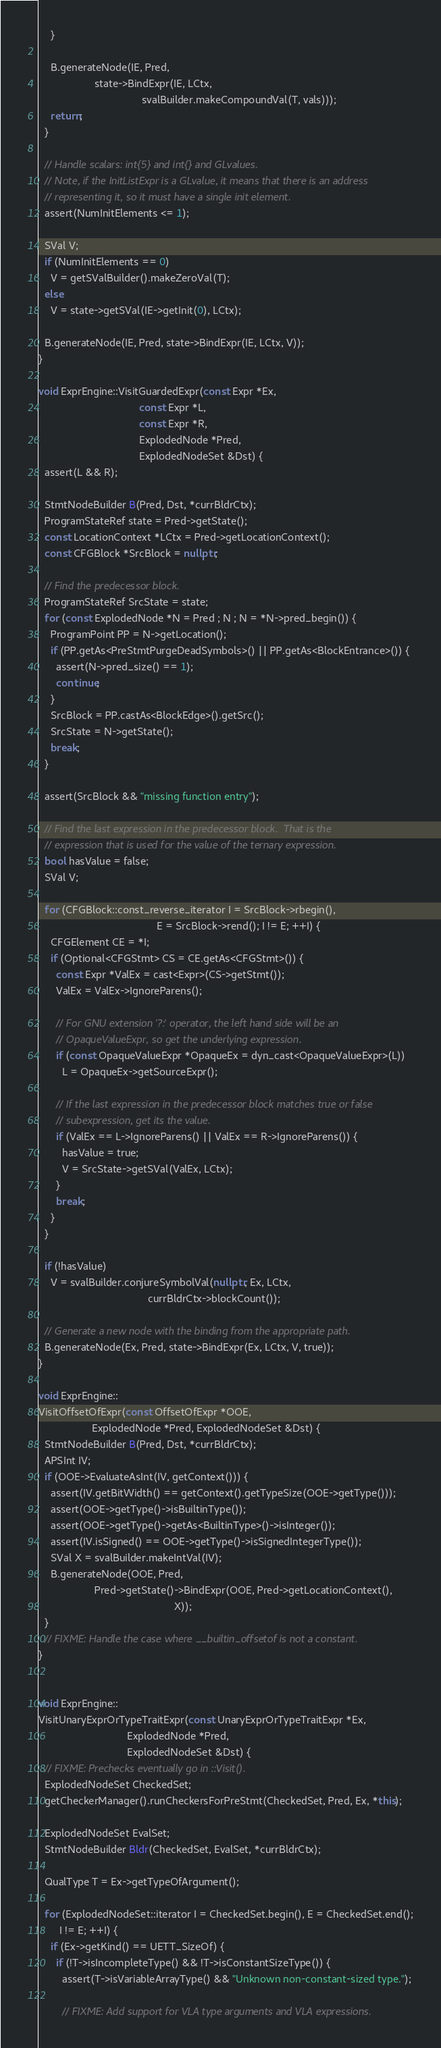<code> <loc_0><loc_0><loc_500><loc_500><_C++_>    }
    
    B.generateNode(IE, Pred,
                   state->BindExpr(IE, LCtx,
                                   svalBuilder.makeCompoundVal(T, vals)));
    return;
  }

  // Handle scalars: int{5} and int{} and GLvalues.
  // Note, if the InitListExpr is a GLvalue, it means that there is an address
  // representing it, so it must have a single init element.
  assert(NumInitElements <= 1);

  SVal V;
  if (NumInitElements == 0)
    V = getSValBuilder().makeZeroVal(T);
  else
    V = state->getSVal(IE->getInit(0), LCtx);

  B.generateNode(IE, Pred, state->BindExpr(IE, LCtx, V));
}

void ExprEngine::VisitGuardedExpr(const Expr *Ex,
                                  const Expr *L, 
                                  const Expr *R,
                                  ExplodedNode *Pred,
                                  ExplodedNodeSet &Dst) {
  assert(L && R);

  StmtNodeBuilder B(Pred, Dst, *currBldrCtx);
  ProgramStateRef state = Pred->getState();
  const LocationContext *LCtx = Pred->getLocationContext();
  const CFGBlock *SrcBlock = nullptr;

  // Find the predecessor block.
  ProgramStateRef SrcState = state;
  for (const ExplodedNode *N = Pred ; N ; N = *N->pred_begin()) {
    ProgramPoint PP = N->getLocation();
    if (PP.getAs<PreStmtPurgeDeadSymbols>() || PP.getAs<BlockEntrance>()) {
      assert(N->pred_size() == 1);
      continue;
    }
    SrcBlock = PP.castAs<BlockEdge>().getSrc();
    SrcState = N->getState();
    break;
  }

  assert(SrcBlock && "missing function entry");

  // Find the last expression in the predecessor block.  That is the
  // expression that is used for the value of the ternary expression.
  bool hasValue = false;
  SVal V;

  for (CFGBlock::const_reverse_iterator I = SrcBlock->rbegin(),
                                        E = SrcBlock->rend(); I != E; ++I) {
    CFGElement CE = *I;
    if (Optional<CFGStmt> CS = CE.getAs<CFGStmt>()) {
      const Expr *ValEx = cast<Expr>(CS->getStmt());
      ValEx = ValEx->IgnoreParens();

      // For GNU extension '?:' operator, the left hand side will be an
      // OpaqueValueExpr, so get the underlying expression.
      if (const OpaqueValueExpr *OpaqueEx = dyn_cast<OpaqueValueExpr>(L))
        L = OpaqueEx->getSourceExpr();

      // If the last expression in the predecessor block matches true or false
      // subexpression, get its the value.
      if (ValEx == L->IgnoreParens() || ValEx == R->IgnoreParens()) {
        hasValue = true;
        V = SrcState->getSVal(ValEx, LCtx);
      }
      break;
    }
  }

  if (!hasValue)
    V = svalBuilder.conjureSymbolVal(nullptr, Ex, LCtx,
                                     currBldrCtx->blockCount());

  // Generate a new node with the binding from the appropriate path.
  B.generateNode(Ex, Pred, state->BindExpr(Ex, LCtx, V, true));
}

void ExprEngine::
VisitOffsetOfExpr(const OffsetOfExpr *OOE, 
                  ExplodedNode *Pred, ExplodedNodeSet &Dst) {
  StmtNodeBuilder B(Pred, Dst, *currBldrCtx);
  APSInt IV;
  if (OOE->EvaluateAsInt(IV, getContext())) {
    assert(IV.getBitWidth() == getContext().getTypeSize(OOE->getType()));
    assert(OOE->getType()->isBuiltinType());
    assert(OOE->getType()->getAs<BuiltinType>()->isInteger());
    assert(IV.isSigned() == OOE->getType()->isSignedIntegerType());
    SVal X = svalBuilder.makeIntVal(IV);
    B.generateNode(OOE, Pred,
                   Pred->getState()->BindExpr(OOE, Pred->getLocationContext(),
                                              X));
  }
  // FIXME: Handle the case where __builtin_offsetof is not a constant.
}


void ExprEngine::
VisitUnaryExprOrTypeTraitExpr(const UnaryExprOrTypeTraitExpr *Ex,
                              ExplodedNode *Pred,
                              ExplodedNodeSet &Dst) {
  // FIXME: Prechecks eventually go in ::Visit().
  ExplodedNodeSet CheckedSet;
  getCheckerManager().runCheckersForPreStmt(CheckedSet, Pred, Ex, *this);

  ExplodedNodeSet EvalSet;
  StmtNodeBuilder Bldr(CheckedSet, EvalSet, *currBldrCtx);

  QualType T = Ex->getTypeOfArgument();

  for (ExplodedNodeSet::iterator I = CheckedSet.begin(), E = CheckedSet.end();
       I != E; ++I) {
    if (Ex->getKind() == UETT_SizeOf) {
      if (!T->isIncompleteType() && !T->isConstantSizeType()) {
        assert(T->isVariableArrayType() && "Unknown non-constant-sized type.");
        
        // FIXME: Add support for VLA type arguments and VLA expressions.</code> 